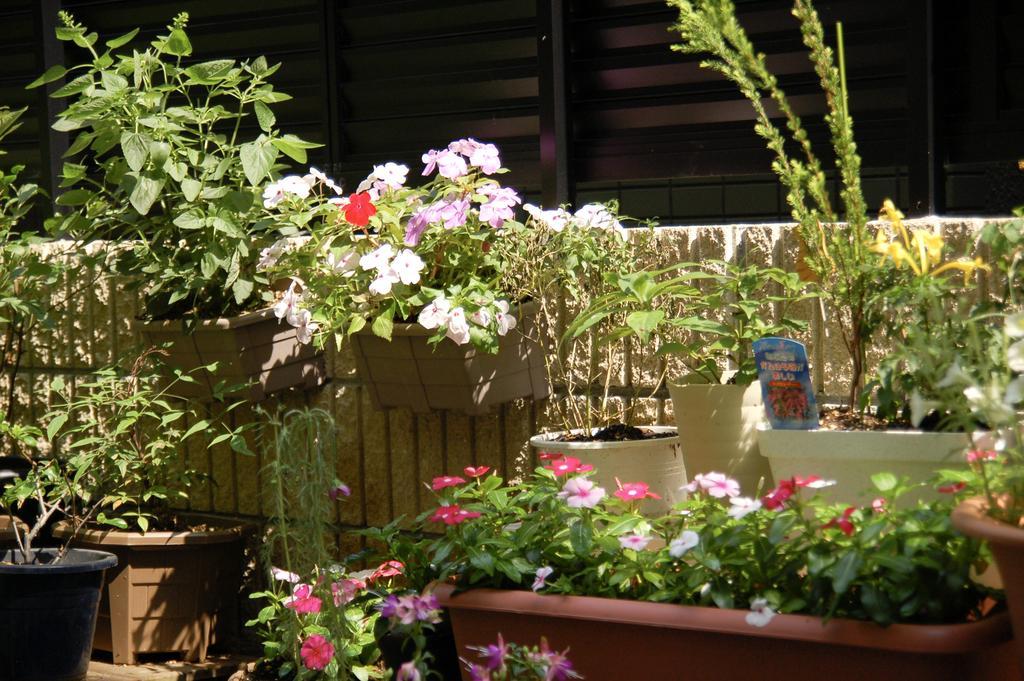How would you summarize this image in a sentence or two? In the image we can see there are many plants. This is a pot and there are many flowers of different color. 